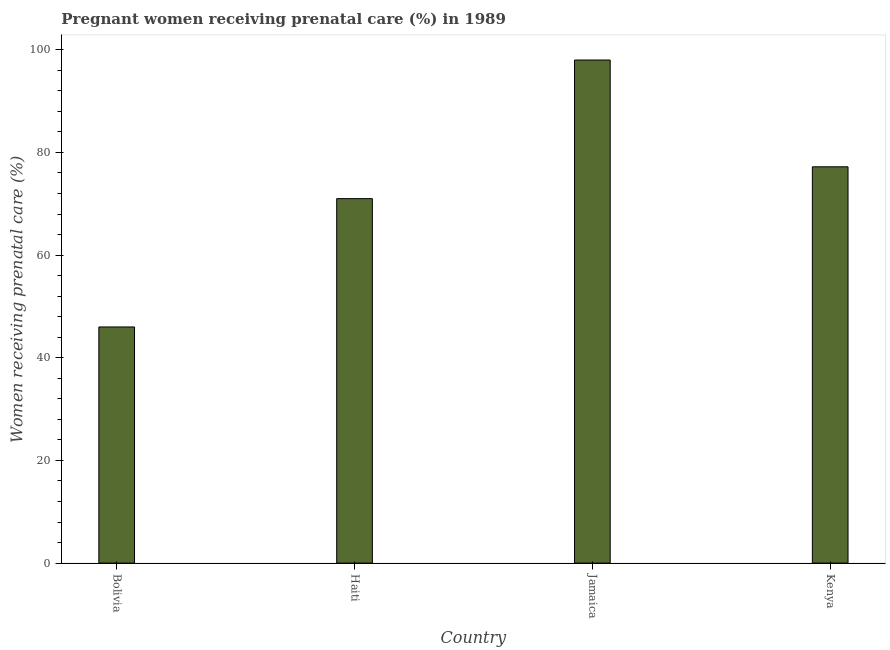Does the graph contain any zero values?
Your answer should be very brief. No. Does the graph contain grids?
Keep it short and to the point. No. What is the title of the graph?
Provide a short and direct response. Pregnant women receiving prenatal care (%) in 1989. What is the label or title of the Y-axis?
Your answer should be compact. Women receiving prenatal care (%). Across all countries, what is the maximum percentage of pregnant women receiving prenatal care?
Ensure brevity in your answer.  98. In which country was the percentage of pregnant women receiving prenatal care maximum?
Provide a succinct answer. Jamaica. What is the sum of the percentage of pregnant women receiving prenatal care?
Ensure brevity in your answer.  292.2. What is the difference between the percentage of pregnant women receiving prenatal care in Bolivia and Jamaica?
Keep it short and to the point. -52. What is the average percentage of pregnant women receiving prenatal care per country?
Provide a succinct answer. 73.05. What is the median percentage of pregnant women receiving prenatal care?
Ensure brevity in your answer.  74.1. In how many countries, is the percentage of pregnant women receiving prenatal care greater than 36 %?
Provide a short and direct response. 4. What is the ratio of the percentage of pregnant women receiving prenatal care in Haiti to that in Jamaica?
Ensure brevity in your answer.  0.72. Is the percentage of pregnant women receiving prenatal care in Haiti less than that in Kenya?
Provide a succinct answer. Yes. What is the difference between the highest and the second highest percentage of pregnant women receiving prenatal care?
Your response must be concise. 20.8. Is the sum of the percentage of pregnant women receiving prenatal care in Bolivia and Haiti greater than the maximum percentage of pregnant women receiving prenatal care across all countries?
Your response must be concise. Yes. What is the difference between the highest and the lowest percentage of pregnant women receiving prenatal care?
Provide a short and direct response. 52. How many bars are there?
Give a very brief answer. 4. Are all the bars in the graph horizontal?
Your answer should be compact. No. How many countries are there in the graph?
Ensure brevity in your answer.  4. Are the values on the major ticks of Y-axis written in scientific E-notation?
Your response must be concise. No. What is the Women receiving prenatal care (%) in Bolivia?
Offer a very short reply. 46. What is the Women receiving prenatal care (%) in Haiti?
Give a very brief answer. 71. What is the Women receiving prenatal care (%) of Kenya?
Your response must be concise. 77.2. What is the difference between the Women receiving prenatal care (%) in Bolivia and Haiti?
Ensure brevity in your answer.  -25. What is the difference between the Women receiving prenatal care (%) in Bolivia and Jamaica?
Your response must be concise. -52. What is the difference between the Women receiving prenatal care (%) in Bolivia and Kenya?
Offer a very short reply. -31.2. What is the difference between the Women receiving prenatal care (%) in Haiti and Jamaica?
Your response must be concise. -27. What is the difference between the Women receiving prenatal care (%) in Haiti and Kenya?
Keep it short and to the point. -6.2. What is the difference between the Women receiving prenatal care (%) in Jamaica and Kenya?
Give a very brief answer. 20.8. What is the ratio of the Women receiving prenatal care (%) in Bolivia to that in Haiti?
Your response must be concise. 0.65. What is the ratio of the Women receiving prenatal care (%) in Bolivia to that in Jamaica?
Your response must be concise. 0.47. What is the ratio of the Women receiving prenatal care (%) in Bolivia to that in Kenya?
Ensure brevity in your answer.  0.6. What is the ratio of the Women receiving prenatal care (%) in Haiti to that in Jamaica?
Give a very brief answer. 0.72. What is the ratio of the Women receiving prenatal care (%) in Jamaica to that in Kenya?
Ensure brevity in your answer.  1.27. 